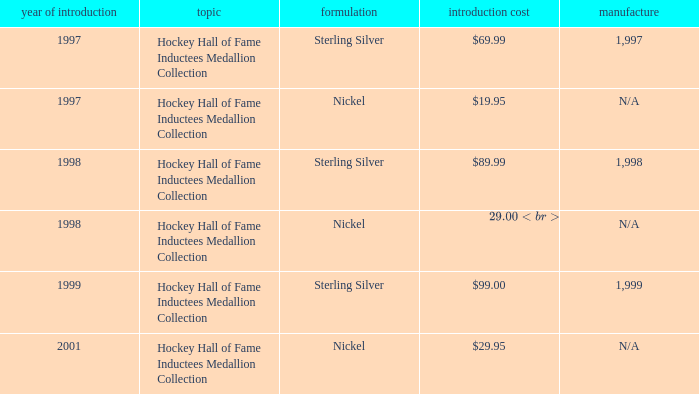How many years was the issue price $19.95? 1.0. 